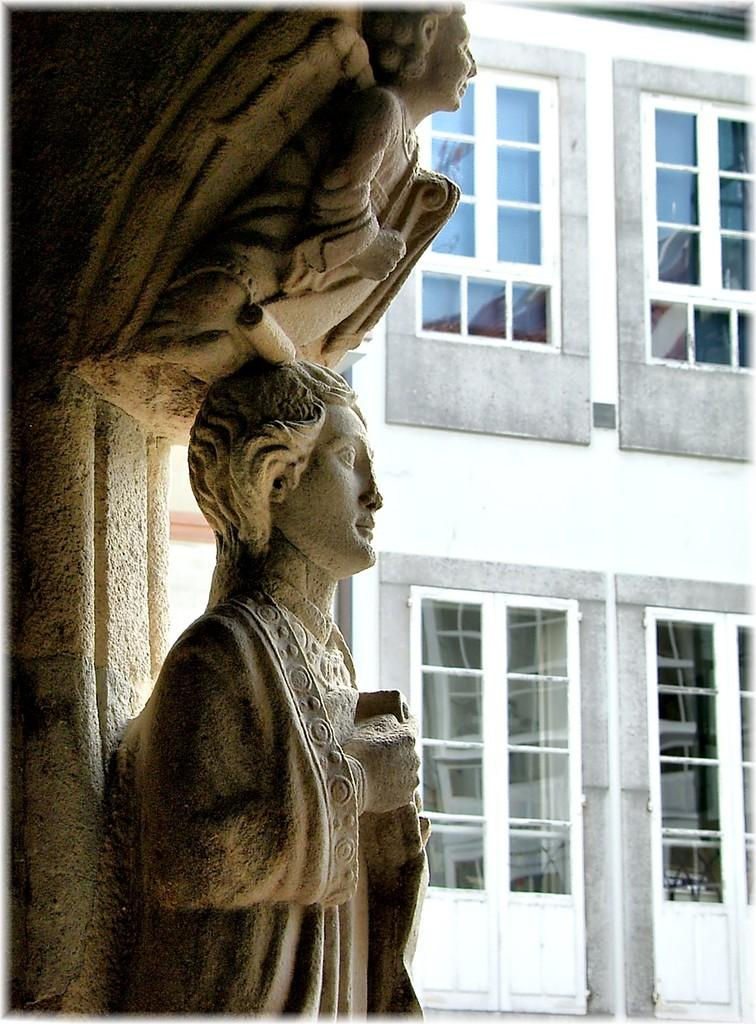What can be seen on the wall in the image? There are sculptures on the wall in the image. What is visible in the background of the image? There is a building visible in the background of the image. What is reflected in the image? There is a reflection of a building in the image. What part of the natural environment can be seen in the reflection? The sky is visible in the reflection. Can you find the receipt for the sculptures in the image? There is no receipt present in the image. Are there any farm animals visible in the image? There are no farm animals present in the image. 